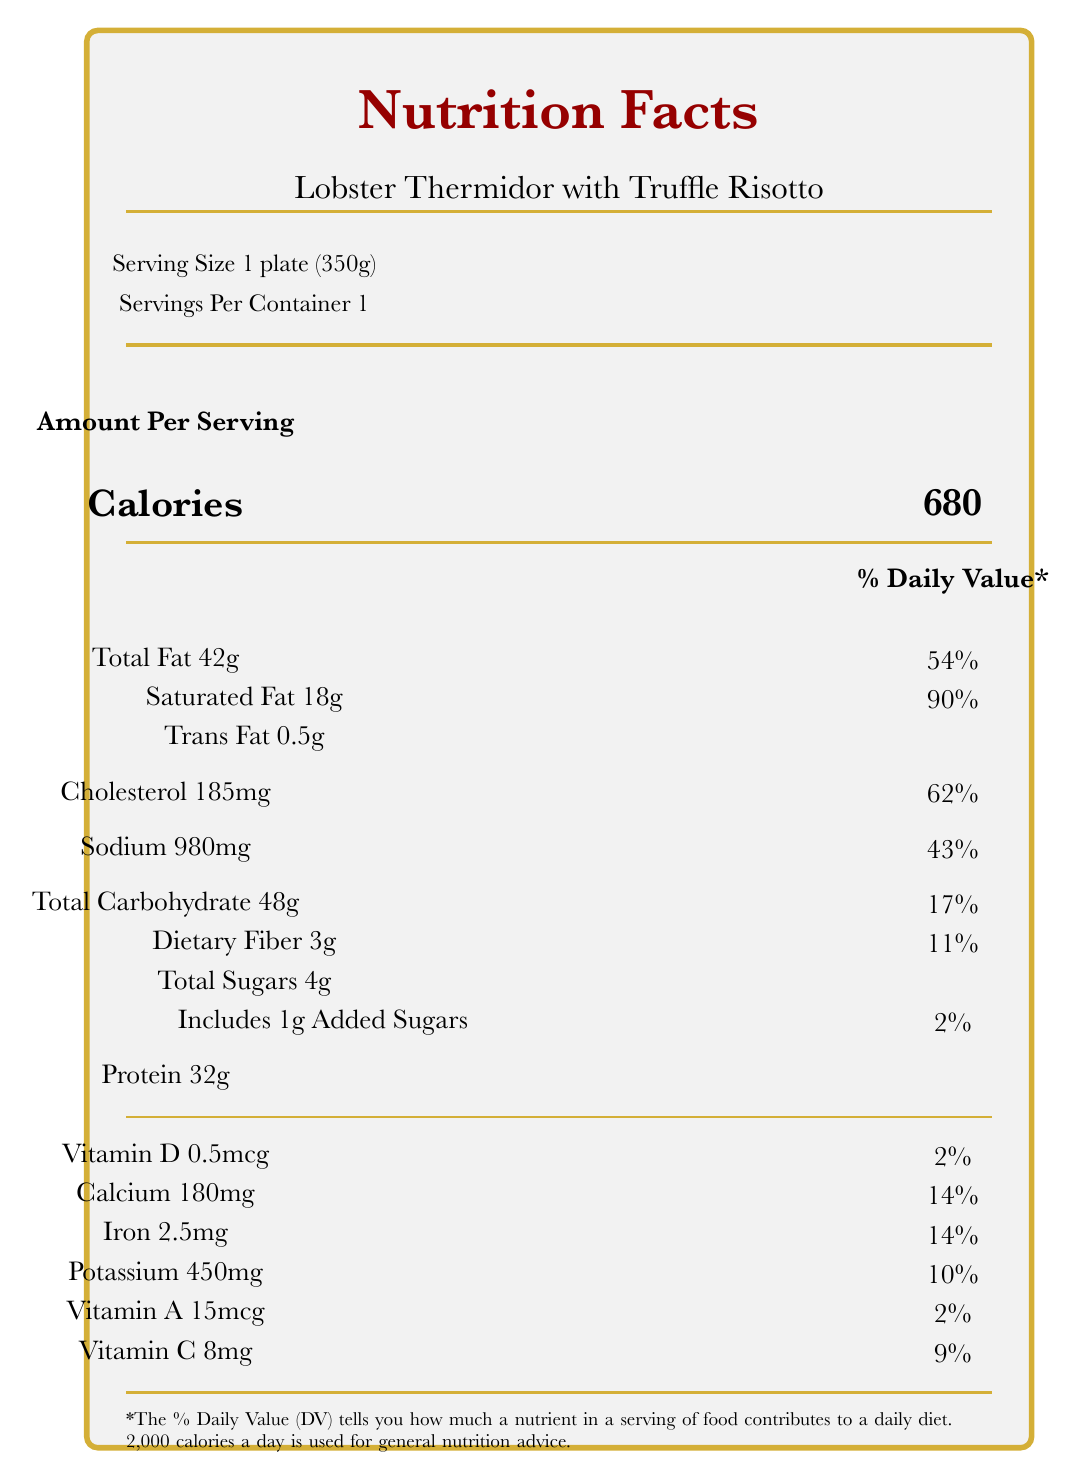what is the serving size? The serving size is specified as 1 plate (350g) in the document.
Answer: 1 plate (350g) how many calories are in one serving? The document states that one serving contains 680 calories.
Answer: 680 what percentage of the daily value is contributed by saturated fat? Saturated fat contributes 90% of the daily value, as indicated in the document.
Answer: 90% how much cholesterol is in one serving? The document lists 185mg of cholesterol per serving.
Answer: 185mg what is the preparation method of the meal? The preparation method is described in the document.
Answer: Poached lobster in a rich cream sauce, served with truffle-infused risotto what is the sodium content per serving? The sodium content is listed as 980mg per serving.
Answer: 980mg what are the allergens present in the meal? A. Shellfish, Milk, Eggs B. Nuts, Soy, Fish C. Wheat, Soy, Nuts The allergens present are Shellfish, Milk, and Eggs.
Answer: A which wine is recommended for pairing with this meal? A. Domaine Laroche Chablis Premier Cru 'Les Vaudevey' 2018 B. Château Margaux 2015 C. Moët & Chandon Brut Impérial The recommended wine pairing is Domaine Laroche Chablis Premier Cru 'Les Vaudevey' 2018.
Answer: A is this meal high in protein? (Yes/No) The meal contains 32g of protein, which is high for a single serving.
Answer: Yes summarize the main idea of the document. The document offers comprehensive nutrition facts for the gourmet dish served at a high-profile art auction gala, connecting the luxurious nature of the meal to the event's atmosphere.
Answer: The document provides a detailed nutritional breakdown of the gourmet meal Lobster Thermidor with Truffle Risotto, including calorie count, macronutrient, and micronutrient information, along with ingredients, allergens, preparation method, and relevance to the art auction context. what is the vitamin C content per serving? The document specifies that each serving contains 8mg of vitamin C.
Answer: 8mg how many grams of trans fat does this meal contain? The meal contains 0.5g of trans fat, as listed in the document.
Answer: 0.5g how does the document relate the meal to the art auction event? The document mentions that the meal's luxurious ingredients mirror the prestige and high value of the artworks being auctioned.
Answer: The opulent dish reflects the luxurious atmosphere of high-profile art auction galas, with ingredients symbolizing the high-value nature of the event. what percentage of the daily value does calcium contribute? Calcium contributes 14% of the daily value per serving, as stated in the document.
Answer: 14% How much iron is in the meal? The document lists 2.5mg of iron per serving.
Answer: 2.5mg what is the daily value percentage for dietary fiber in the meal? The dietary fiber content contributes 11% of the daily value.
Answer: 11% does the document provide specific recommendations for physical activity or other dietary information beyond the meal? The document only provides nutritional information for the specific meal and does not include additional dietary or physical activity recommendations.
Answer: No what impact does the meal's nutritional content have on bidding at the auction? The document explains that the nutritional content may affect bidders' energy and focus during the auction.
Answer: The high calorie and fat content may influence energy levels and decision-making, while the complex carbohydrates and proteins could provide sustained energy, affecting bidding stamina and focus. does the meal include any added sugars? The document specifies that the meal includes 1g of added sugars.
Answer: Yes, 1g what is the total carbohydrate content in the meal per serving? The total carbohydrate content is listed as 48g per serving.
Answer: 48g how much butter is used in the preparation of this meal? The document does not specify the amount of butter used in the preparation.
Answer: Not enough information 